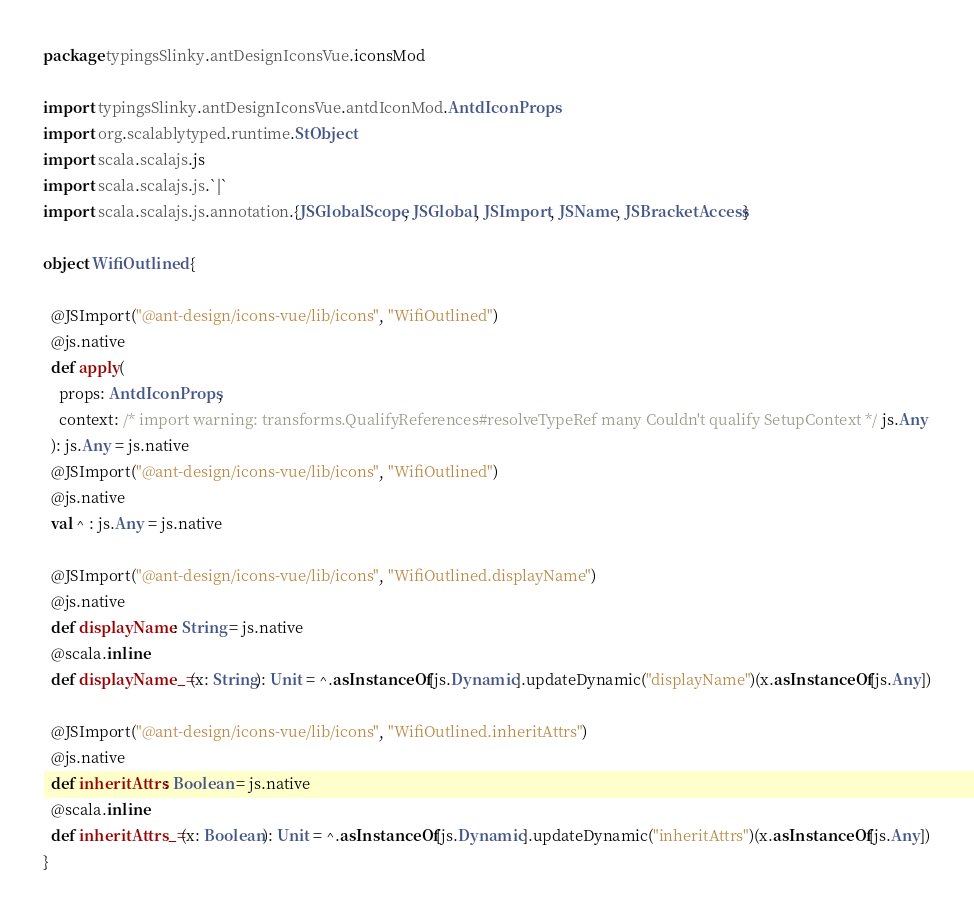Convert code to text. <code><loc_0><loc_0><loc_500><loc_500><_Scala_>package typingsSlinky.antDesignIconsVue.iconsMod

import typingsSlinky.antDesignIconsVue.antdIconMod.AntdIconProps
import org.scalablytyped.runtime.StObject
import scala.scalajs.js
import scala.scalajs.js.`|`
import scala.scalajs.js.annotation.{JSGlobalScope, JSGlobal, JSImport, JSName, JSBracketAccess}

object WifiOutlined {
  
  @JSImport("@ant-design/icons-vue/lib/icons", "WifiOutlined")
  @js.native
  def apply(
    props: AntdIconProps,
    context: /* import warning: transforms.QualifyReferences#resolveTypeRef many Couldn't qualify SetupContext */ js.Any
  ): js.Any = js.native
  @JSImport("@ant-design/icons-vue/lib/icons", "WifiOutlined")
  @js.native
  val ^ : js.Any = js.native
  
  @JSImport("@ant-design/icons-vue/lib/icons", "WifiOutlined.displayName")
  @js.native
  def displayName: String = js.native
  @scala.inline
  def displayName_=(x: String): Unit = ^.asInstanceOf[js.Dynamic].updateDynamic("displayName")(x.asInstanceOf[js.Any])
  
  @JSImport("@ant-design/icons-vue/lib/icons", "WifiOutlined.inheritAttrs")
  @js.native
  def inheritAttrs: Boolean = js.native
  @scala.inline
  def inheritAttrs_=(x: Boolean): Unit = ^.asInstanceOf[js.Dynamic].updateDynamic("inheritAttrs")(x.asInstanceOf[js.Any])
}
</code> 